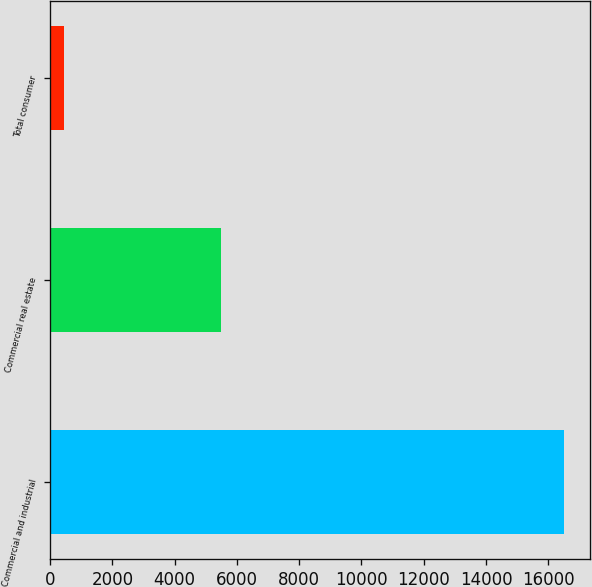Convert chart to OTSL. <chart><loc_0><loc_0><loc_500><loc_500><bar_chart><fcel>Commercial and industrial<fcel>Commercial real estate<fcel>Total consumer<nl><fcel>16507<fcel>5473<fcel>431<nl></chart> 